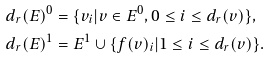Convert formula to latex. <formula><loc_0><loc_0><loc_500><loc_500>d _ { r } ( E ) ^ { 0 } & = \{ v _ { i } | v \in E ^ { 0 } , 0 \leq i \leq d _ { r } ( v ) \} , \\ d _ { r } ( E ) ^ { 1 } & = E ^ { 1 } \cup \{ f ( v ) _ { i } | 1 \leq i \leq d _ { r } ( v ) \} .</formula> 